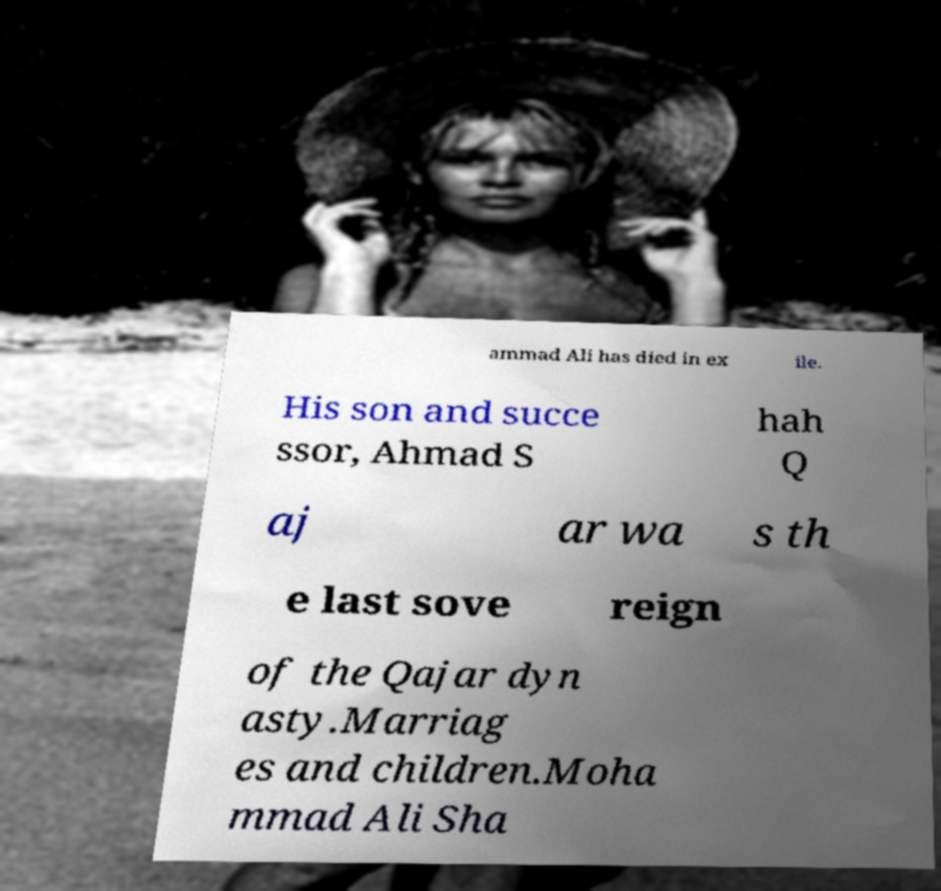Can you read and provide the text displayed in the image?This photo seems to have some interesting text. Can you extract and type it out for me? ammad Ali has died in ex ile. His son and succe ssor, Ahmad S hah Q aj ar wa s th e last sove reign of the Qajar dyn asty.Marriag es and children.Moha mmad Ali Sha 